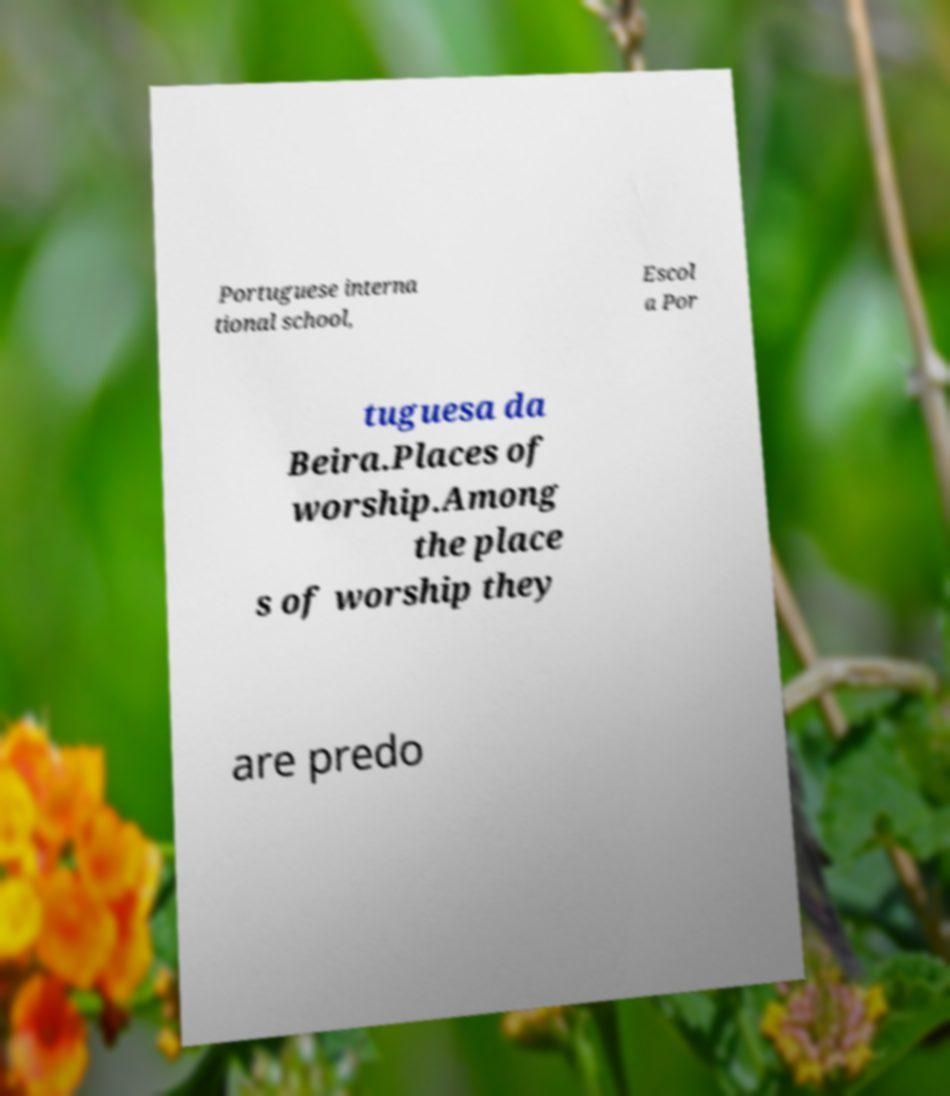Could you extract and type out the text from this image? Portuguese interna tional school, Escol a Por tuguesa da Beira.Places of worship.Among the place s of worship they are predo 